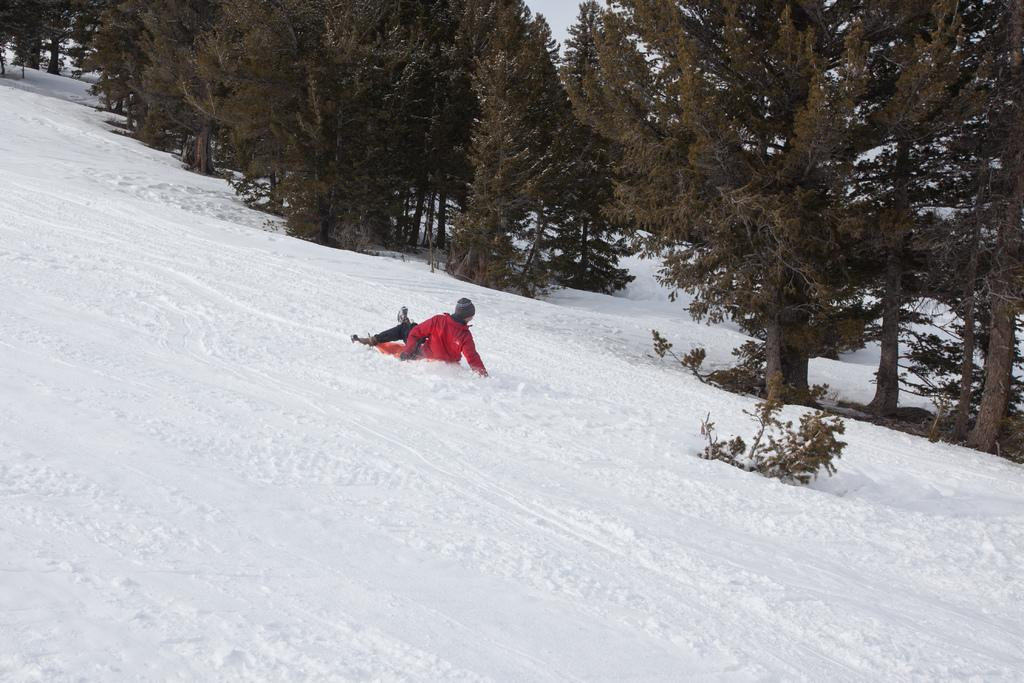Who or what is the main subject in the center of the image? There is a person in the center of the image. What type of weather condition is depicted at the bottom of the image? There is snow at the bottom of the image. What can be seen in the background of the image? There are trees in the background of the image. Where is the market located in the image? There is no market present in the image. What type of hospital can be seen in the background of the image? There is no hospital present in the image; only trees are visible in the background. 